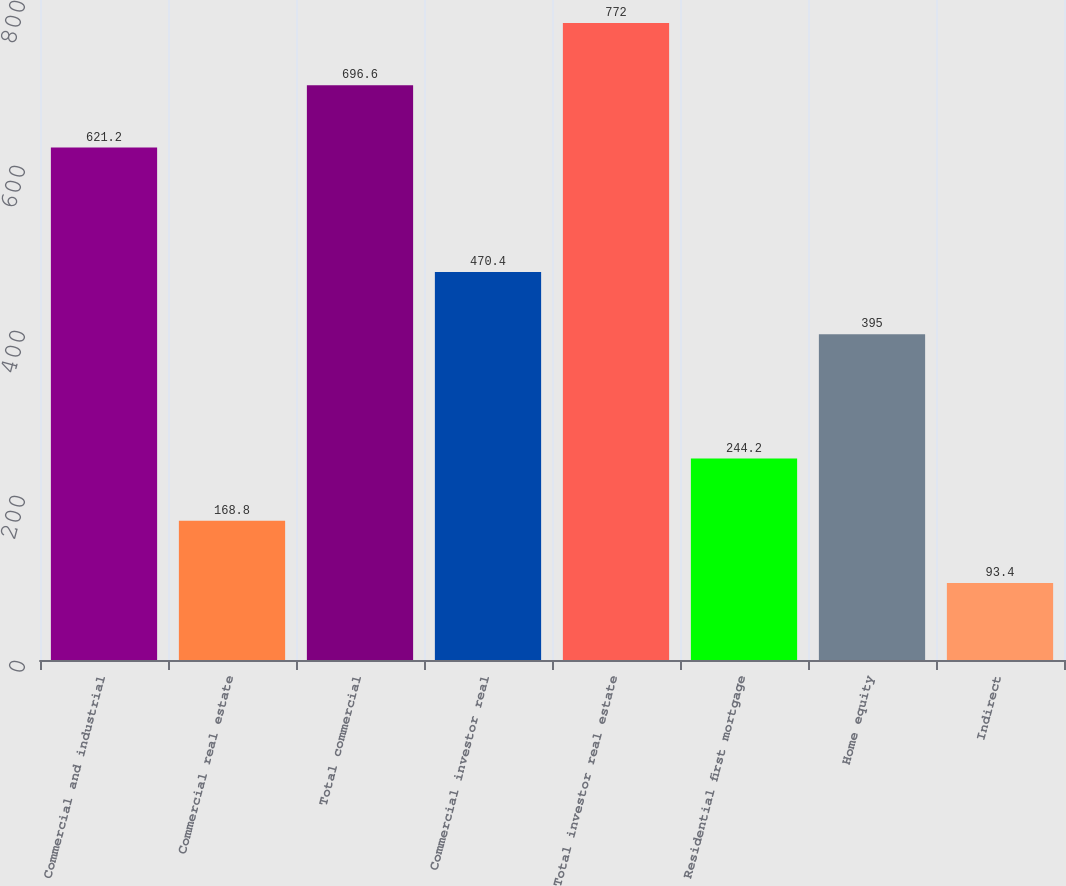Convert chart to OTSL. <chart><loc_0><loc_0><loc_500><loc_500><bar_chart><fcel>Commercial and industrial<fcel>Commercial real estate<fcel>Total commercial<fcel>Commercial investor real<fcel>Total investor real estate<fcel>Residential first mortgage<fcel>Home equity<fcel>Indirect<nl><fcel>621.2<fcel>168.8<fcel>696.6<fcel>470.4<fcel>772<fcel>244.2<fcel>395<fcel>93.4<nl></chart> 